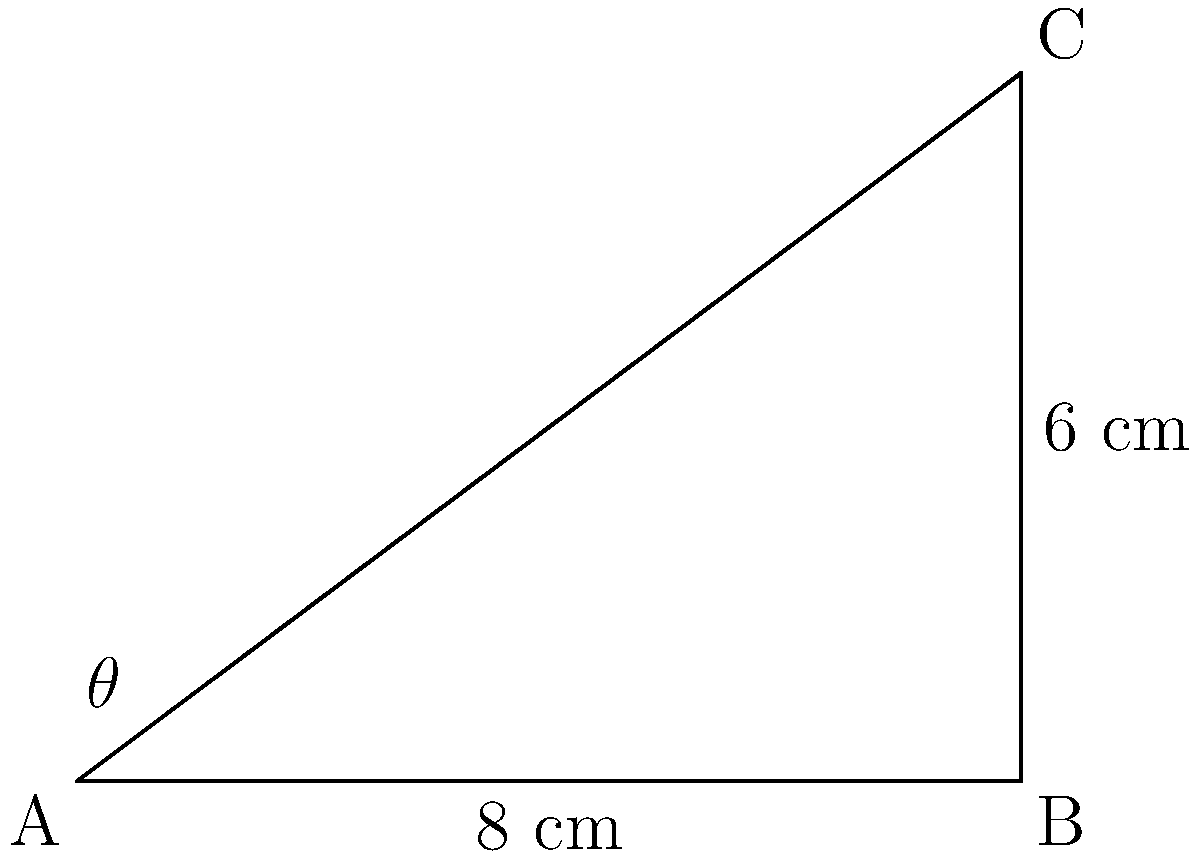As a landscape painter adapting to vision loss, you're exploring new techniques for canvas preparation. You want to create a triangular canvas frame for a unique mountain scene. The base of the triangle is 8 cm, and the height is 6 cm. What is the angle $\theta$ (in degrees) between the base and the hypotenuse of this triangular frame? To find the angle $\theta$, we can use the trigonometric function tangent (tan). Here's how:

1) In a right-angled triangle, $\tan \theta = \frac{\text{opposite}}{\text{adjacent}}$

2) In this case:
   - The opposite side is the height of the triangle: 6 cm
   - The adjacent side is the base of the triangle: 8 cm

3) So, we can write:
   $\tan \theta = \frac{6}{8} = 0.75$

4) To find $\theta$, we need to use the inverse tangent function (arctan or $\tan^{-1}$):
   $\theta = \tan^{-1}(0.75)$

5) Using a calculator or trigonometric tables:
   $\theta \approx 36.87°$

6) Rounding to the nearest degree:
   $\theta \approx 37°$
Answer: $37°$ 